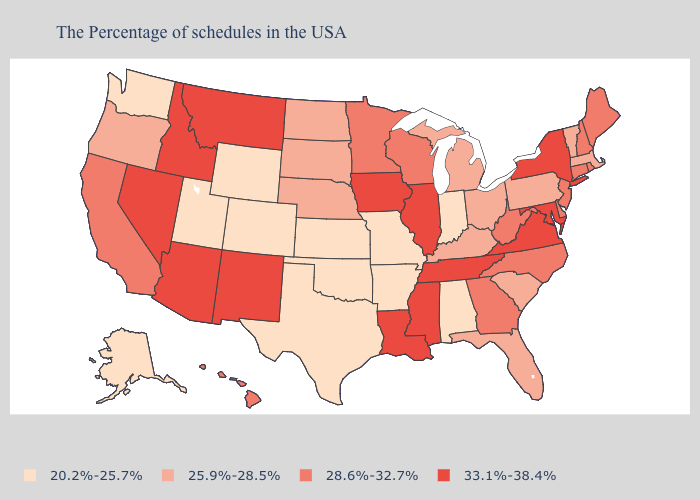Which states have the lowest value in the USA?
Write a very short answer. Indiana, Alabama, Missouri, Arkansas, Kansas, Oklahoma, Texas, Wyoming, Colorado, Utah, Washington, Alaska. Name the states that have a value in the range 28.6%-32.7%?
Give a very brief answer. Maine, Rhode Island, New Hampshire, Connecticut, New Jersey, Delaware, North Carolina, West Virginia, Georgia, Wisconsin, Minnesota, California, Hawaii. Does the map have missing data?
Quick response, please. No. What is the value of New Mexico?
Give a very brief answer. 33.1%-38.4%. What is the value of Maryland?
Concise answer only. 33.1%-38.4%. Does the map have missing data?
Write a very short answer. No. Is the legend a continuous bar?
Keep it brief. No. What is the value of Delaware?
Quick response, please. 28.6%-32.7%. What is the lowest value in the USA?
Answer briefly. 20.2%-25.7%. Name the states that have a value in the range 28.6%-32.7%?
Give a very brief answer. Maine, Rhode Island, New Hampshire, Connecticut, New Jersey, Delaware, North Carolina, West Virginia, Georgia, Wisconsin, Minnesota, California, Hawaii. Which states have the lowest value in the Northeast?
Concise answer only. Massachusetts, Vermont, Pennsylvania. Name the states that have a value in the range 28.6%-32.7%?
Write a very short answer. Maine, Rhode Island, New Hampshire, Connecticut, New Jersey, Delaware, North Carolina, West Virginia, Georgia, Wisconsin, Minnesota, California, Hawaii. Name the states that have a value in the range 33.1%-38.4%?
Concise answer only. New York, Maryland, Virginia, Tennessee, Illinois, Mississippi, Louisiana, Iowa, New Mexico, Montana, Arizona, Idaho, Nevada. Does Idaho have the same value as Mississippi?
Be succinct. Yes. What is the highest value in states that border Missouri?
Short answer required. 33.1%-38.4%. 